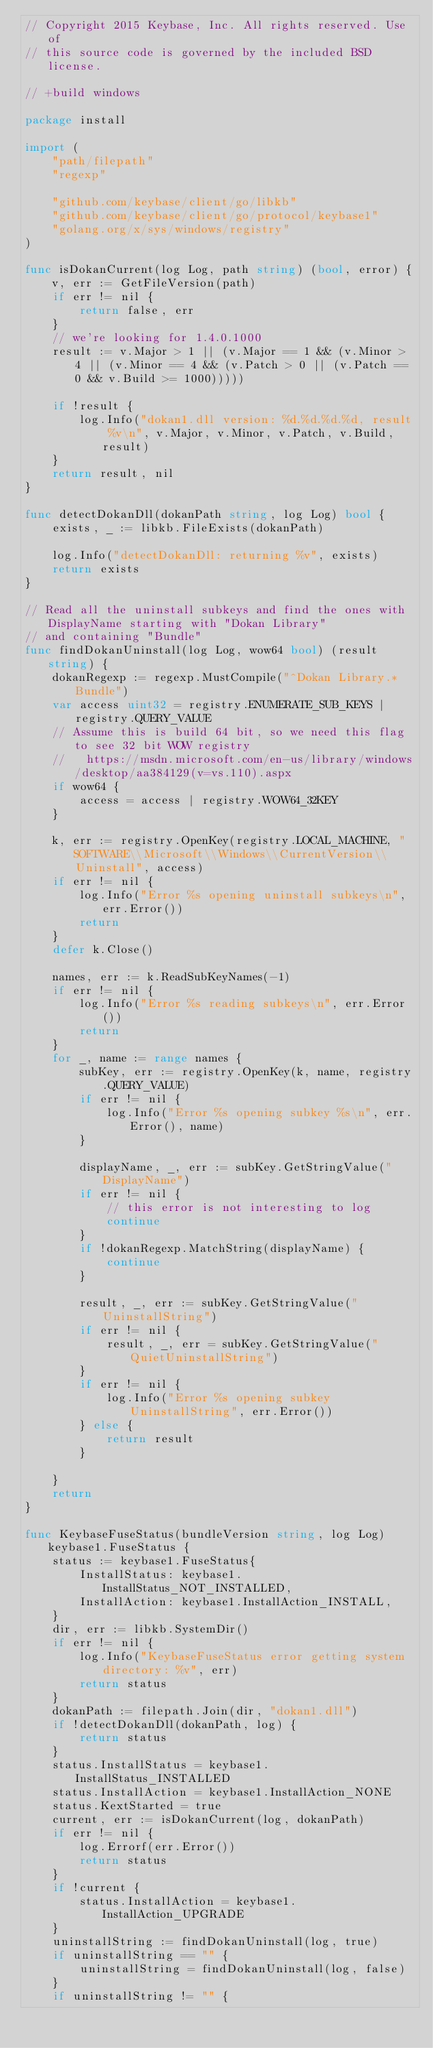<code> <loc_0><loc_0><loc_500><loc_500><_Go_>// Copyright 2015 Keybase, Inc. All rights reserved. Use of
// this source code is governed by the included BSD license.

// +build windows

package install

import (
	"path/filepath"
	"regexp"

	"github.com/keybase/client/go/libkb"
	"github.com/keybase/client/go/protocol/keybase1"
	"golang.org/x/sys/windows/registry"
)

func isDokanCurrent(log Log, path string) (bool, error) {
	v, err := GetFileVersion(path)
	if err != nil {
		return false, err
	}
	// we're looking for 1.4.0.1000
	result := v.Major > 1 || (v.Major == 1 && (v.Minor > 4 || (v.Minor == 4 && (v.Patch > 0 || (v.Patch == 0 && v.Build >= 1000)))))

	if !result {
		log.Info("dokan1.dll version: %d.%d.%d.%d, result %v\n", v.Major, v.Minor, v.Patch, v.Build, result)
	}
	return result, nil
}

func detectDokanDll(dokanPath string, log Log) bool {
	exists, _ := libkb.FileExists(dokanPath)

	log.Info("detectDokanDll: returning %v", exists)
	return exists
}

// Read all the uninstall subkeys and find the ones with DisplayName starting with "Dokan Library"
// and containing "Bundle"
func findDokanUninstall(log Log, wow64 bool) (result string) {
	dokanRegexp := regexp.MustCompile("^Dokan Library.*Bundle")
	var access uint32 = registry.ENUMERATE_SUB_KEYS | registry.QUERY_VALUE
	// Assume this is build 64 bit, so we need this flag to see 32 bit WOW registry
	//   https://msdn.microsoft.com/en-us/library/windows/desktop/aa384129(v=vs.110).aspx
	if wow64 {
		access = access | registry.WOW64_32KEY
	}

	k, err := registry.OpenKey(registry.LOCAL_MACHINE, "SOFTWARE\\Microsoft\\Windows\\CurrentVersion\\Uninstall", access)
	if err != nil {
		log.Info("Error %s opening uninstall subkeys\n", err.Error())
		return
	}
	defer k.Close()

	names, err := k.ReadSubKeyNames(-1)
	if err != nil {
		log.Info("Error %s reading subkeys\n", err.Error())
		return
	}
	for _, name := range names {
		subKey, err := registry.OpenKey(k, name, registry.QUERY_VALUE)
		if err != nil {
			log.Info("Error %s opening subkey %s\n", err.Error(), name)
		}

		displayName, _, err := subKey.GetStringValue("DisplayName")
		if err != nil {
			// this error is not interesting to log
			continue
		}
		if !dokanRegexp.MatchString(displayName) {
			continue
		}

		result, _, err := subKey.GetStringValue("UninstallString")
		if err != nil {
			result, _, err = subKey.GetStringValue("QuietUninstallString")
		}
		if err != nil {
			log.Info("Error %s opening subkey UninstallString", err.Error())
		} else {
			return result
		}

	}
	return
}

func KeybaseFuseStatus(bundleVersion string, log Log) keybase1.FuseStatus {
	status := keybase1.FuseStatus{
		InstallStatus: keybase1.InstallStatus_NOT_INSTALLED,
		InstallAction: keybase1.InstallAction_INSTALL,
	}
	dir, err := libkb.SystemDir()
	if err != nil {
		log.Info("KeybaseFuseStatus error getting system directory: %v", err)
		return status
	}
	dokanPath := filepath.Join(dir, "dokan1.dll")
	if !detectDokanDll(dokanPath, log) {
		return status
	}
	status.InstallStatus = keybase1.InstallStatus_INSTALLED
	status.InstallAction = keybase1.InstallAction_NONE
	status.KextStarted = true
	current, err := isDokanCurrent(log, dokanPath)
	if err != nil {
		log.Errorf(err.Error())
		return status
	}
	if !current {
		status.InstallAction = keybase1.InstallAction_UPGRADE
	}
	uninstallString := findDokanUninstall(log, true)
	if uninstallString == "" {
		uninstallString = findDokanUninstall(log, false)
	}
	if uninstallString != "" {</code> 